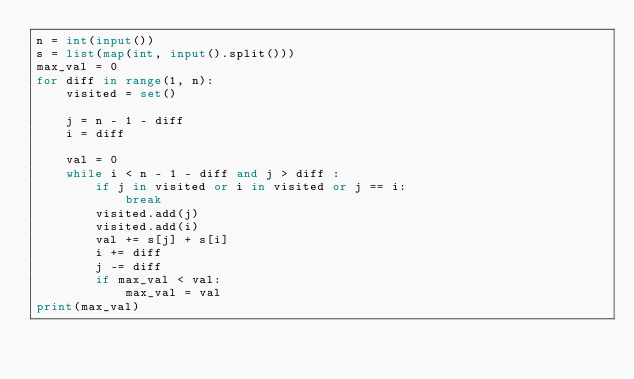<code> <loc_0><loc_0><loc_500><loc_500><_Python_>n = int(input())
s = list(map(int, input().split()))
max_val = 0
for diff in range(1, n):
    visited = set()

    j = n - 1 - diff
    i = diff

    val = 0
    while i < n - 1 - diff and j > diff :
        if j in visited or i in visited or j == i:
            break
        visited.add(j)
        visited.add(i)
        val += s[j] + s[i]
        i += diff
        j -= diff
        if max_val < val:
            max_val = val
print(max_val)</code> 